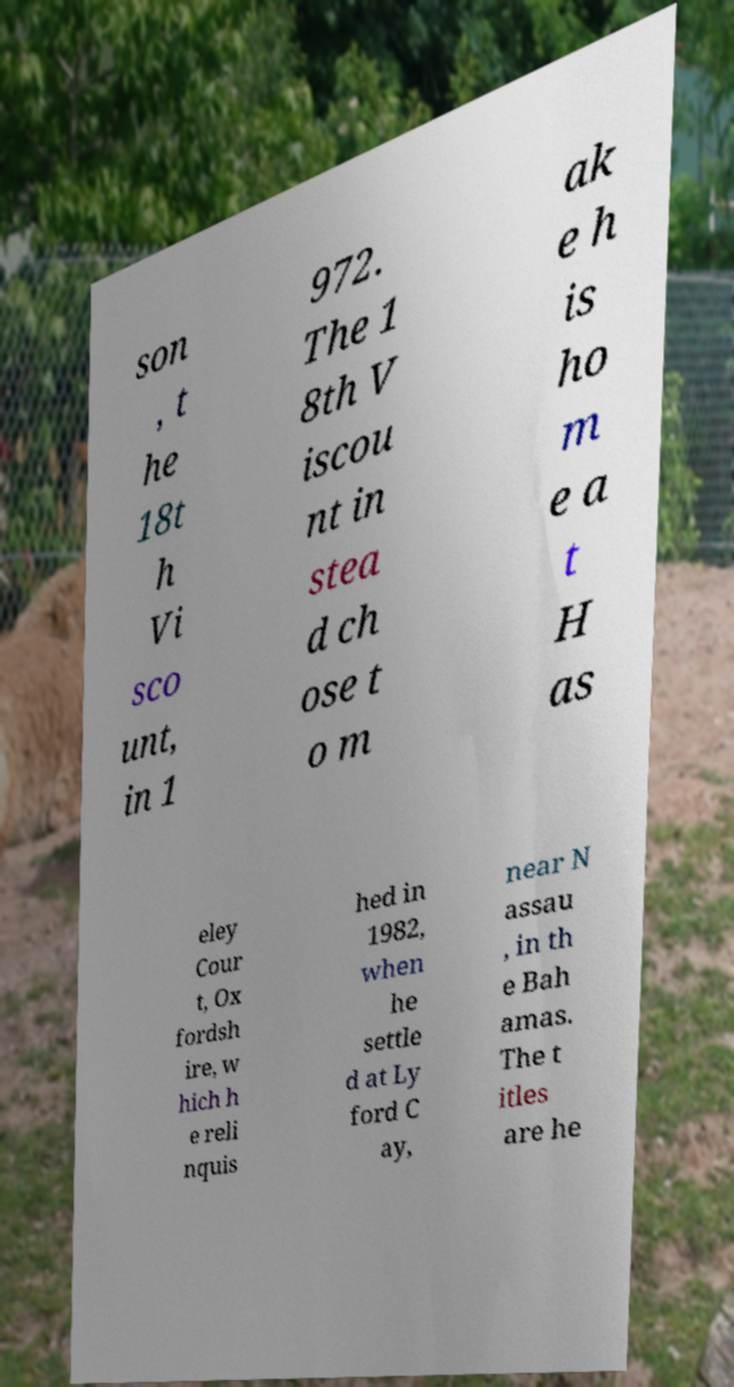There's text embedded in this image that I need extracted. Can you transcribe it verbatim? son , t he 18t h Vi sco unt, in 1 972. The 1 8th V iscou nt in stea d ch ose t o m ak e h is ho m e a t H as eley Cour t, Ox fordsh ire, w hich h e reli nquis hed in 1982, when he settle d at Ly ford C ay, near N assau , in th e Bah amas. The t itles are he 